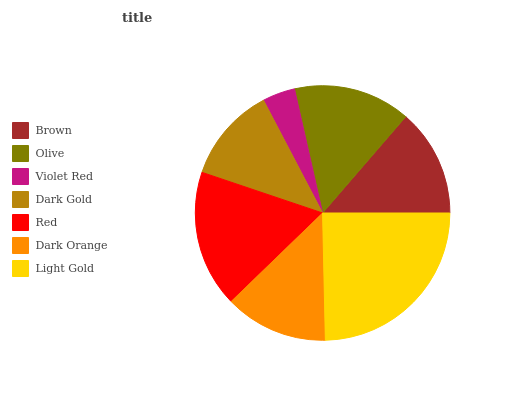Is Violet Red the minimum?
Answer yes or no. Yes. Is Light Gold the maximum?
Answer yes or no. Yes. Is Olive the minimum?
Answer yes or no. No. Is Olive the maximum?
Answer yes or no. No. Is Olive greater than Brown?
Answer yes or no. Yes. Is Brown less than Olive?
Answer yes or no. Yes. Is Brown greater than Olive?
Answer yes or no. No. Is Olive less than Brown?
Answer yes or no. No. Is Brown the high median?
Answer yes or no. Yes. Is Brown the low median?
Answer yes or no. Yes. Is Violet Red the high median?
Answer yes or no. No. Is Dark Gold the low median?
Answer yes or no. No. 